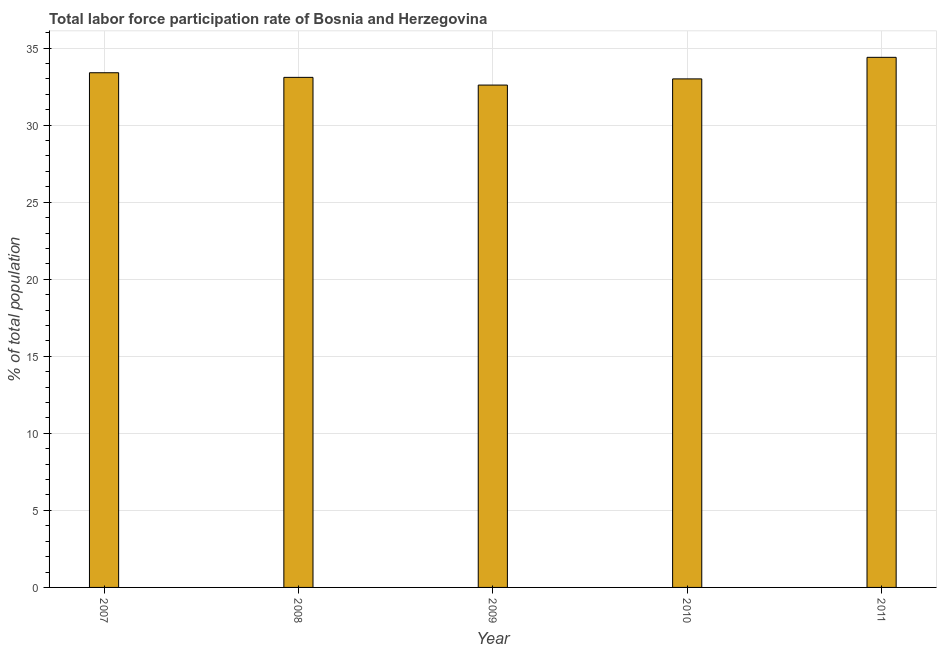Does the graph contain grids?
Keep it short and to the point. Yes. What is the title of the graph?
Your answer should be compact. Total labor force participation rate of Bosnia and Herzegovina. What is the label or title of the Y-axis?
Give a very brief answer. % of total population. What is the total labor force participation rate in 2010?
Provide a succinct answer. 33. Across all years, what is the maximum total labor force participation rate?
Offer a very short reply. 34.4. Across all years, what is the minimum total labor force participation rate?
Your answer should be compact. 32.6. In which year was the total labor force participation rate maximum?
Provide a short and direct response. 2011. What is the sum of the total labor force participation rate?
Keep it short and to the point. 166.5. What is the average total labor force participation rate per year?
Provide a short and direct response. 33.3. What is the median total labor force participation rate?
Provide a short and direct response. 33.1. In how many years, is the total labor force participation rate greater than 6 %?
Provide a succinct answer. 5. What is the ratio of the total labor force participation rate in 2009 to that in 2011?
Your response must be concise. 0.95. Is the total labor force participation rate in 2008 less than that in 2009?
Your answer should be compact. No. Is the sum of the total labor force participation rate in 2010 and 2011 greater than the maximum total labor force participation rate across all years?
Make the answer very short. Yes. What is the difference between the highest and the lowest total labor force participation rate?
Give a very brief answer. 1.8. In how many years, is the total labor force participation rate greater than the average total labor force participation rate taken over all years?
Ensure brevity in your answer.  2. Are the values on the major ticks of Y-axis written in scientific E-notation?
Ensure brevity in your answer.  No. What is the % of total population in 2007?
Give a very brief answer. 33.4. What is the % of total population of 2008?
Offer a terse response. 33.1. What is the % of total population in 2009?
Keep it short and to the point. 32.6. What is the % of total population of 2011?
Make the answer very short. 34.4. What is the difference between the % of total population in 2008 and 2009?
Ensure brevity in your answer.  0.5. What is the difference between the % of total population in 2008 and 2010?
Offer a terse response. 0.1. What is the difference between the % of total population in 2010 and 2011?
Give a very brief answer. -1.4. What is the ratio of the % of total population in 2007 to that in 2008?
Your answer should be very brief. 1.01. What is the ratio of the % of total population in 2007 to that in 2009?
Give a very brief answer. 1.02. What is the ratio of the % of total population in 2007 to that in 2010?
Provide a succinct answer. 1.01. What is the ratio of the % of total population in 2008 to that in 2010?
Offer a terse response. 1. What is the ratio of the % of total population in 2008 to that in 2011?
Make the answer very short. 0.96. What is the ratio of the % of total population in 2009 to that in 2010?
Keep it short and to the point. 0.99. What is the ratio of the % of total population in 2009 to that in 2011?
Your answer should be very brief. 0.95. What is the ratio of the % of total population in 2010 to that in 2011?
Give a very brief answer. 0.96. 